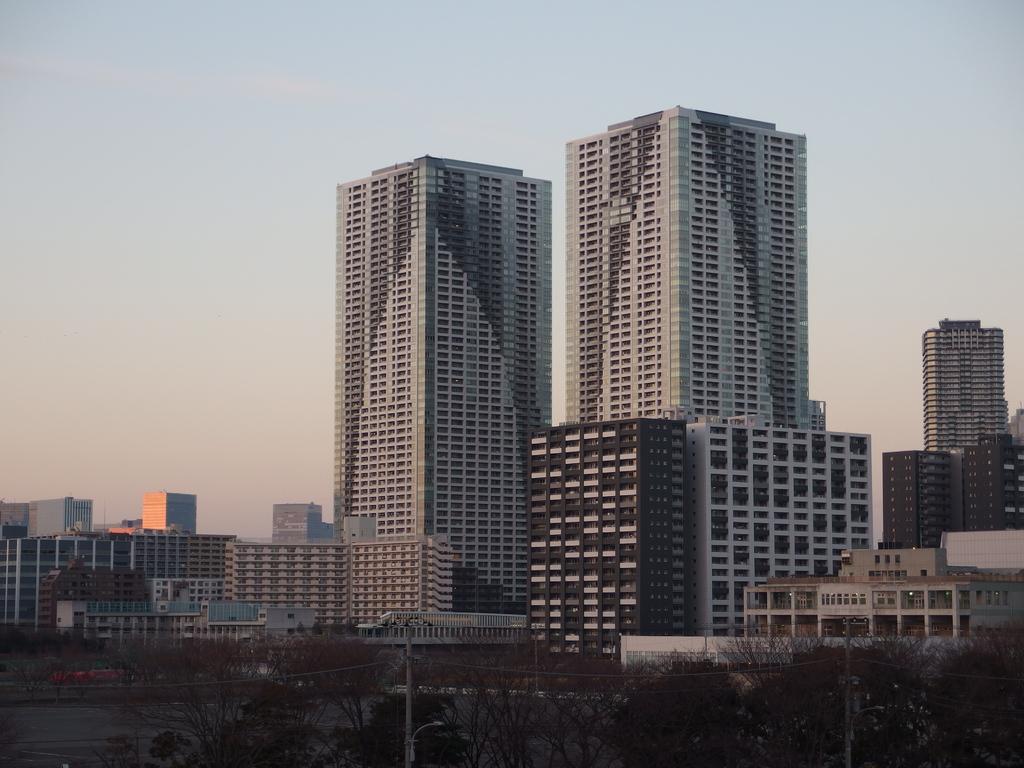In one or two sentences, can you explain what this image depicts? There are buildings, trees and water on the ground. In the background, there are clouds in the blue sky. 